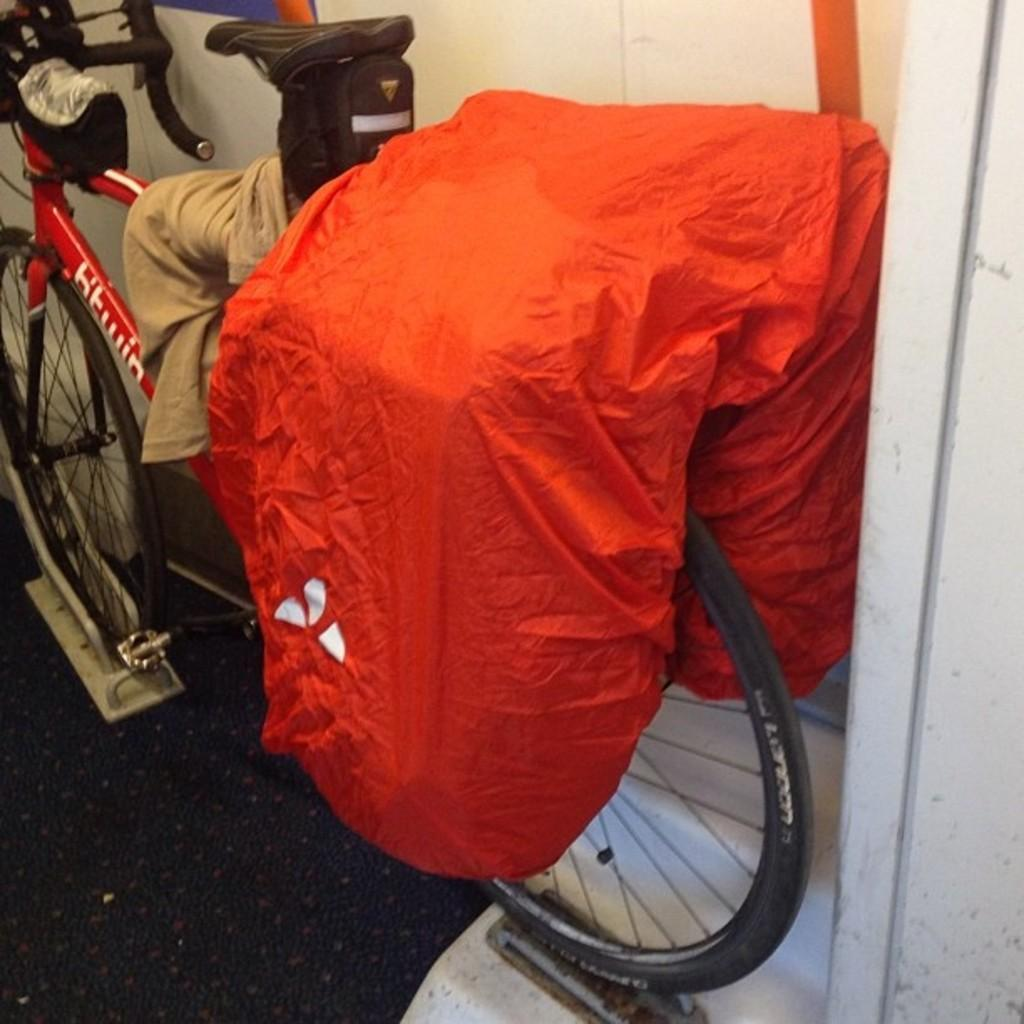What object is the main subject of the image? There is a bicycle in the image. Where is the bicycle located? The bicycle is placed on the floor. What is hanging on the bicycle? There are clothes on the bicycle. What can be seen in the background of the image? There is a wall in the background of the image. What type of ice can be seen melting on the bicycle in the image? There is no ice present on the bicycle in the image. What reason is given for the clothes being hung on the bicycle in the image? The image does not provide a reason for the clothes being hung on the bicycle; it only shows the bicycle with clothes on it. 